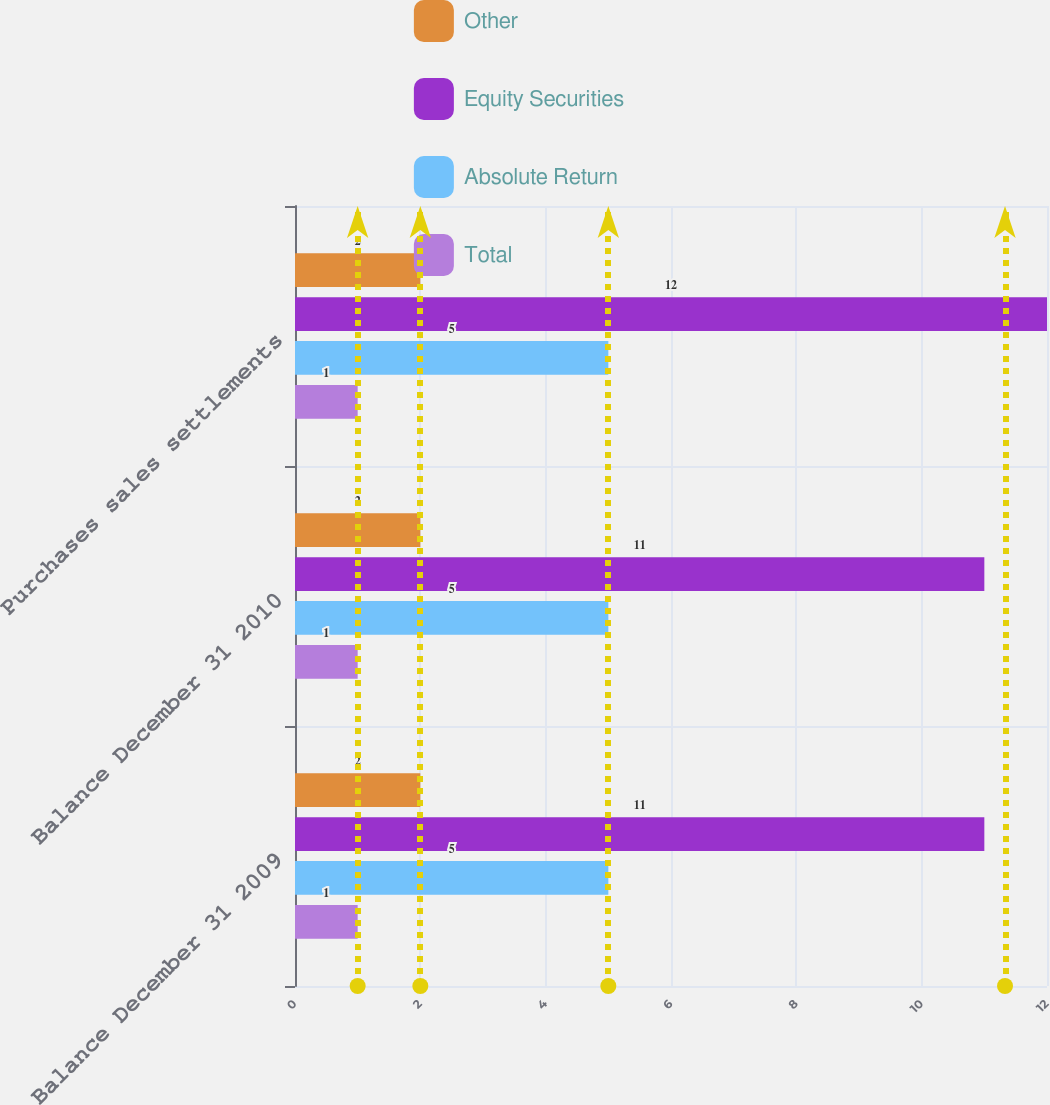<chart> <loc_0><loc_0><loc_500><loc_500><stacked_bar_chart><ecel><fcel>Balance December 31 2009<fcel>Balance December 31 2010<fcel>Purchases sales settlements<nl><fcel>Other<fcel>2<fcel>2<fcel>2<nl><fcel>Equity Securities<fcel>11<fcel>11<fcel>12<nl><fcel>Absolute Return<fcel>5<fcel>5<fcel>5<nl><fcel>Total<fcel>1<fcel>1<fcel>1<nl></chart> 